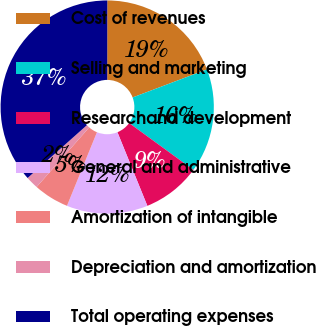Convert chart to OTSL. <chart><loc_0><loc_0><loc_500><loc_500><pie_chart><fcel>Cost of revenues<fcel>Selling and marketing<fcel>Researchand development<fcel>General and administrative<fcel>Amortization of intangible<fcel>Depreciation and amortization<fcel>Total operating expenses<nl><fcel>19.24%<fcel>15.77%<fcel>8.83%<fcel>12.3%<fcel>5.36%<fcel>1.9%<fcel>36.59%<nl></chart> 